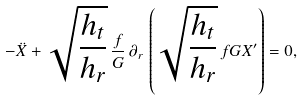Convert formula to latex. <formula><loc_0><loc_0><loc_500><loc_500>- \ddot { X } + \sqrt { \frac { h _ { t } } { h _ { r } } } \, \frac { f } { G } \, \partial _ { r } \, \left ( \sqrt { \frac { h _ { t } } { h _ { r } } } \, f G X ^ { \prime } \right ) = 0 ,</formula> 